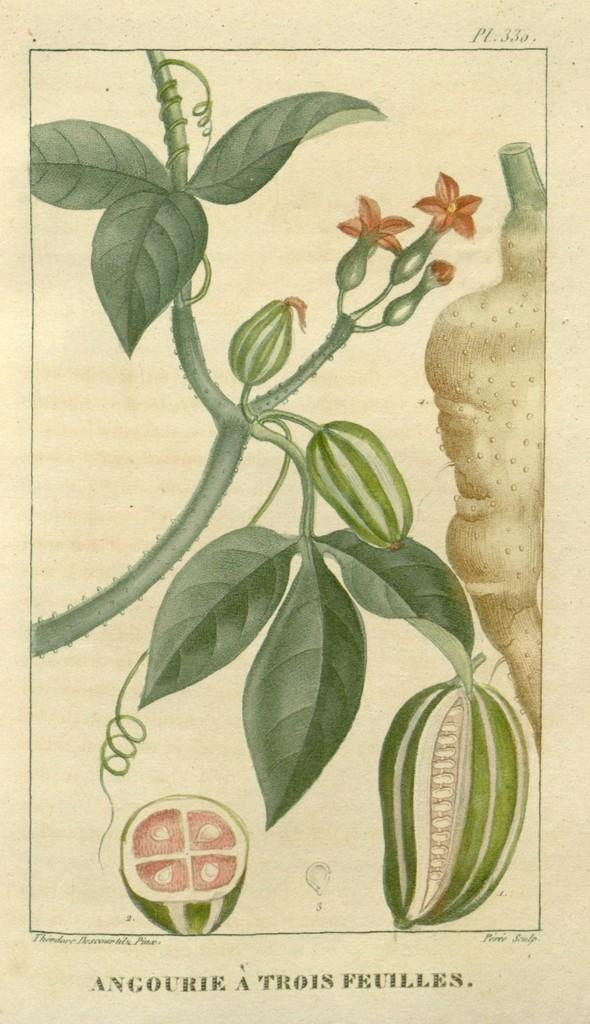What type of image is being described? The image appears to be an art piece. Is there any text present in the image? Yes, there is some text at the bottom of the image. How many parents can be seen in the image? There are no parents present in the image, as it is an art piece and not a photograph or scene with people. 